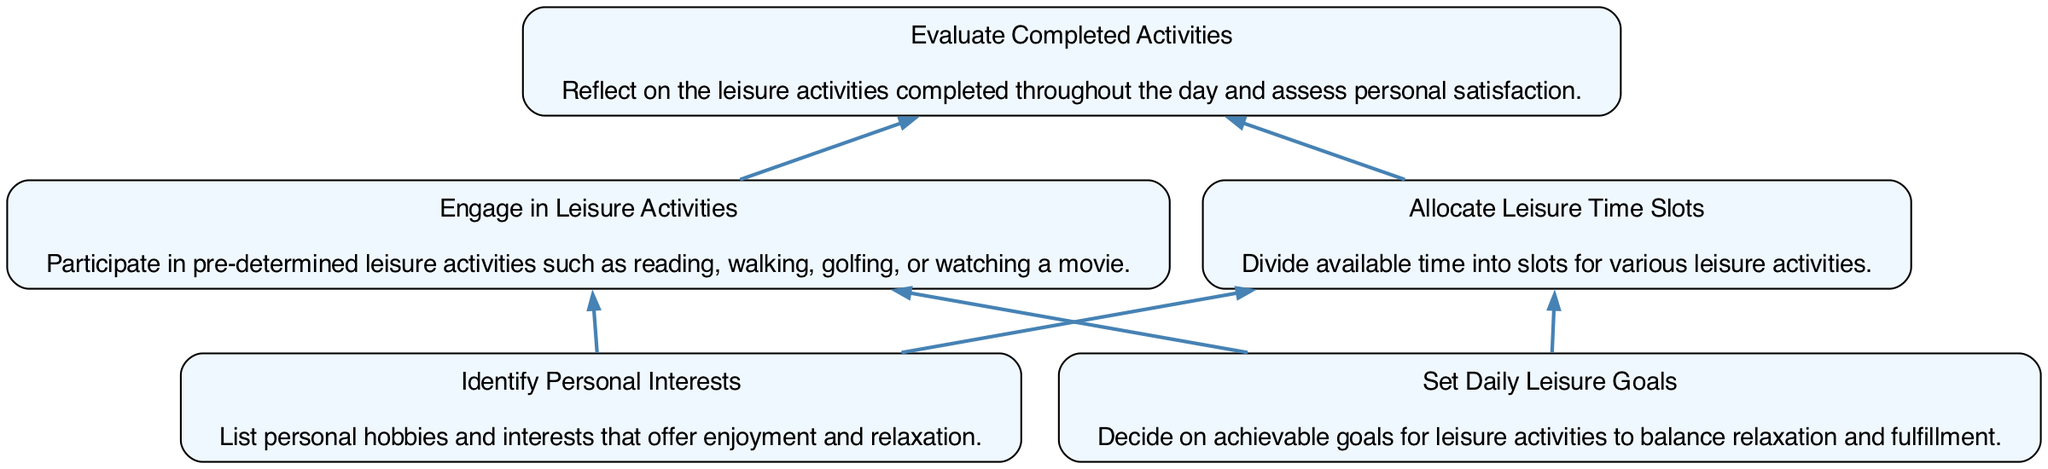What is the first step in the daily leisure time planning process? The first step in the process is "Identify Personal Interests," which is located at the bottom of the diagram. This node serves as the starting point for planning.
Answer: Identify Personal Interests How many nodes are in the diagram? The diagram contains five nodes representing different steps in the leisure time planning process.
Answer: Five What description is associated with the "Engage in Leisure Activities" node? The description associated with this node is "Participate in pre-determined leisure activities such as reading, walking, golfing, or watching a movie." This information is found directly below the node in the diagram.
Answer: Participate in pre-determined leisure activities such as reading, walking, golfing, or watching a movie Which node is directly connected to "Set Daily Leisure Goals"? The node directly connected to "Set Daily Leisure Goals" is "Allocate Leisure Time Slots". This is determined by tracing the upward flow from the bottom node to the connected middle node.
Answer: Allocate Leisure Time Slots Which node comes at the top of the flow chart? The top node is "Evaluate Completed Activities," representing the final step in the process of planning leisure time, indicating a reflective conclusion.
Answer: Evaluate Completed Activities For the "Allocate Leisure Time Slots", how does it relate to the other nodes? "Allocate Leisure Time Slots" can be viewed as a transitional step connecting two significant aspects: it follows the identification of personal interests and daily goals while leading into engaging in leisure activities, thus linking the foundational planning phase to active participation.
Answer: It connects personal interests and daily goals to engaging in leisure activities What is the last action to take in the daily leisure planning process? The last action in the process is "Evaluate Completed Activities." This is the final step, which reflects on the experiences of the day.
Answer: Evaluate Completed Activities Which actions should you do after identifying personal interests? After identifying personal interests, the next actions are to "Set Daily Leisure Goals" and "Allocate Leisure Time Slots." Both these actions are crucial for effective leisure planning following the identification phase.
Answer: Set Daily Leisure Goals and Allocate Leisure Time Slots What is the overall purpose of the flow chart? The overall purpose of the flow chart is to guide individuals through a structured process of planning leisure time, ensuring that all aspects from identifying interests to evaluating activities are considered.
Answer: To guide through structured leisure time planning 